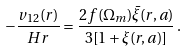Convert formula to latex. <formula><loc_0><loc_0><loc_500><loc_500>- \frac { v _ { 1 2 } ( r ) } { H r } = \frac { 2 f ( \Omega _ { m } ) \bar { \xi } ( r , a ) } { 3 [ 1 + \xi ( r , a ) ] } \, .</formula> 